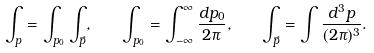Convert formula to latex. <formula><loc_0><loc_0><loc_500><loc_500>\int _ { p } = \int _ { p _ { 0 } } \int _ { \vec { p } } , \quad \int _ { p _ { 0 } } = \int _ { - \infty } ^ { \infty } \frac { d p _ { 0 } } { 2 \pi } , \quad \int _ { \vec { p } } = \int \frac { d ^ { 3 } p } { ( 2 \pi ) ^ { 3 } } .</formula> 